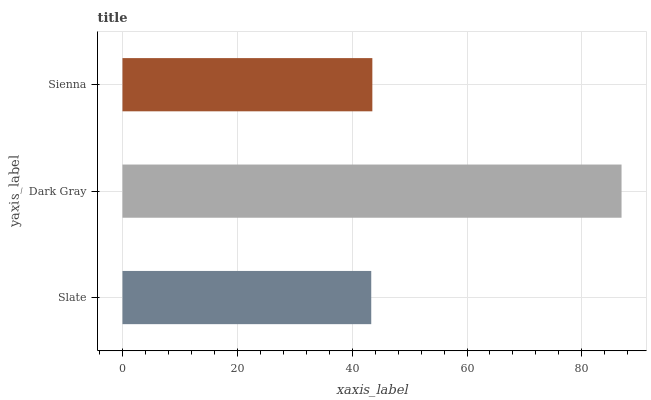Is Slate the minimum?
Answer yes or no. Yes. Is Dark Gray the maximum?
Answer yes or no. Yes. Is Sienna the minimum?
Answer yes or no. No. Is Sienna the maximum?
Answer yes or no. No. Is Dark Gray greater than Sienna?
Answer yes or no. Yes. Is Sienna less than Dark Gray?
Answer yes or no. Yes. Is Sienna greater than Dark Gray?
Answer yes or no. No. Is Dark Gray less than Sienna?
Answer yes or no. No. Is Sienna the high median?
Answer yes or no. Yes. Is Sienna the low median?
Answer yes or no. Yes. Is Slate the high median?
Answer yes or no. No. Is Dark Gray the low median?
Answer yes or no. No. 